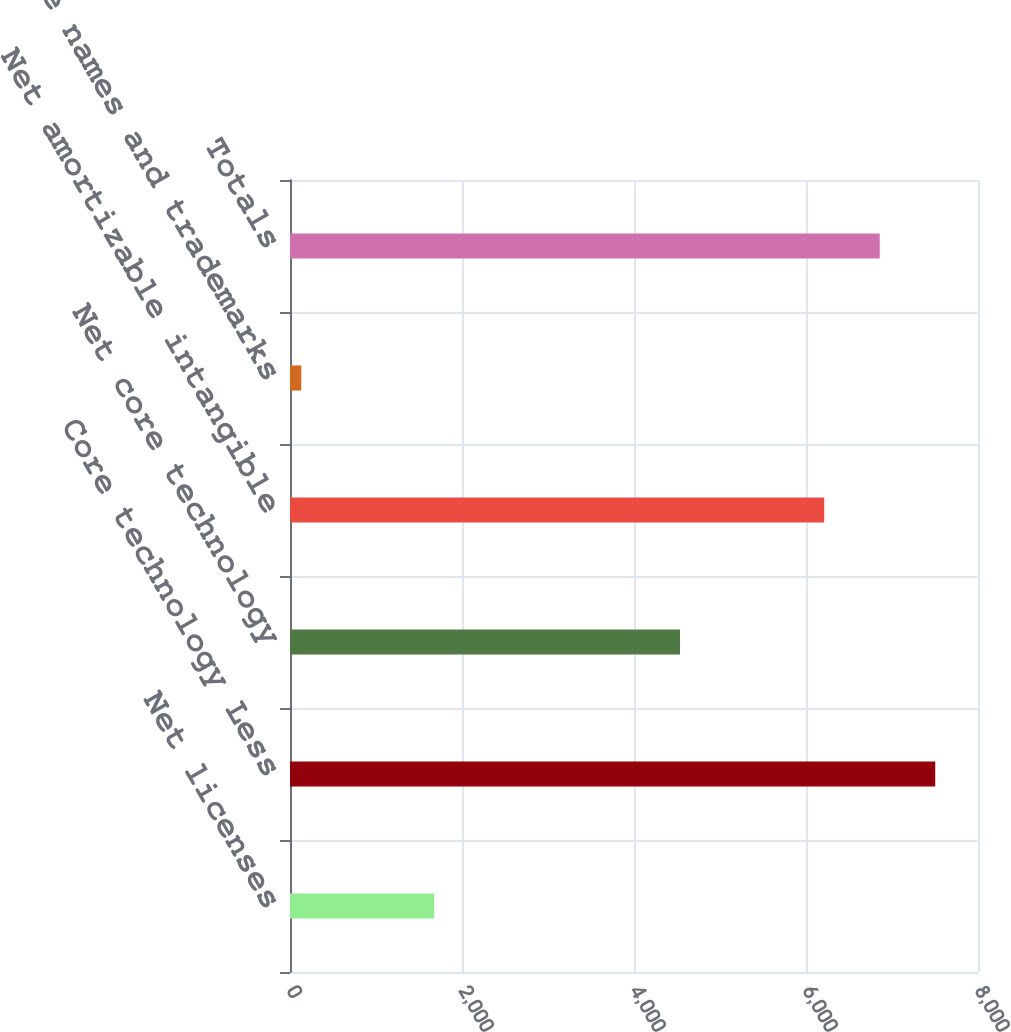<chart> <loc_0><loc_0><loc_500><loc_500><bar_chart><fcel>Net licenses<fcel>Core technology Less<fcel>Net core technology<fcel>Net amortizable intangible<fcel>Trade names and trademarks<fcel>Totals<nl><fcel>1677<fcel>7502.8<fcel>4535<fcel>6212<fcel>131<fcel>6857.4<nl></chart> 